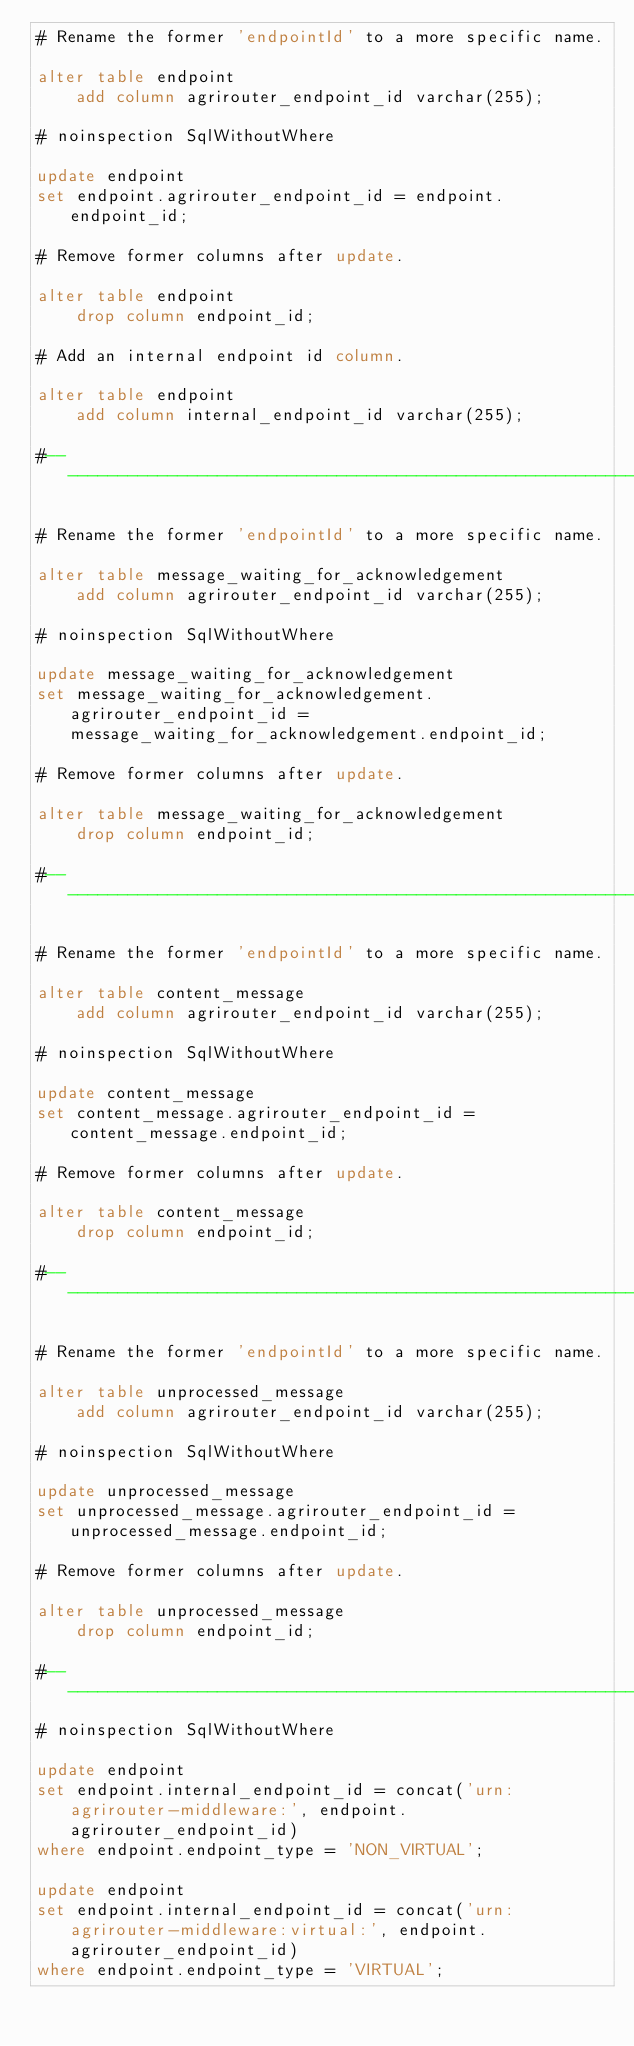Convert code to text. <code><loc_0><loc_0><loc_500><loc_500><_SQL_># Rename the former 'endpointId' to a more specific name.

alter table endpoint
    add column agrirouter_endpoint_id varchar(255);

# noinspection SqlWithoutWhere

update endpoint
set endpoint.agrirouter_endpoint_id = endpoint.endpoint_id;

# Remove former columns after update.

alter table endpoint
    drop column endpoint_id;

# Add an internal endpoint id column.

alter table endpoint
    add column internal_endpoint_id varchar(255);

#---------------------------------------------------------------------------------------------------------------------#

# Rename the former 'endpointId' to a more specific name.

alter table message_waiting_for_acknowledgement
    add column agrirouter_endpoint_id varchar(255);

# noinspection SqlWithoutWhere

update message_waiting_for_acknowledgement
set message_waiting_for_acknowledgement.agrirouter_endpoint_id = message_waiting_for_acknowledgement.endpoint_id;

# Remove former columns after update.

alter table message_waiting_for_acknowledgement
    drop column endpoint_id;

#---------------------------------------------------------------------------------------------------------------------#

# Rename the former 'endpointId' to a more specific name.

alter table content_message
    add column agrirouter_endpoint_id varchar(255);

# noinspection SqlWithoutWhere

update content_message
set content_message.agrirouter_endpoint_id = content_message.endpoint_id;

# Remove former columns after update.

alter table content_message
    drop column endpoint_id;

#---------------------------------------------------------------------------------------------------------------------#

# Rename the former 'endpointId' to a more specific name.

alter table unprocessed_message
    add column agrirouter_endpoint_id varchar(255);

# noinspection SqlWithoutWhere

update unprocessed_message
set unprocessed_message.agrirouter_endpoint_id = unprocessed_message.endpoint_id;

# Remove former columns after update.

alter table unprocessed_message
    drop column endpoint_id;

#---------------------------------------------------------------------------------------------------------------------#
# noinspection SqlWithoutWhere

update endpoint
set endpoint.internal_endpoint_id = concat('urn:agrirouter-middleware:', endpoint.agrirouter_endpoint_id)
where endpoint.endpoint_type = 'NON_VIRTUAL';

update endpoint
set endpoint.internal_endpoint_id = concat('urn:agrirouter-middleware:virtual:', endpoint.agrirouter_endpoint_id)
where endpoint.endpoint_type = 'VIRTUAL';

</code> 